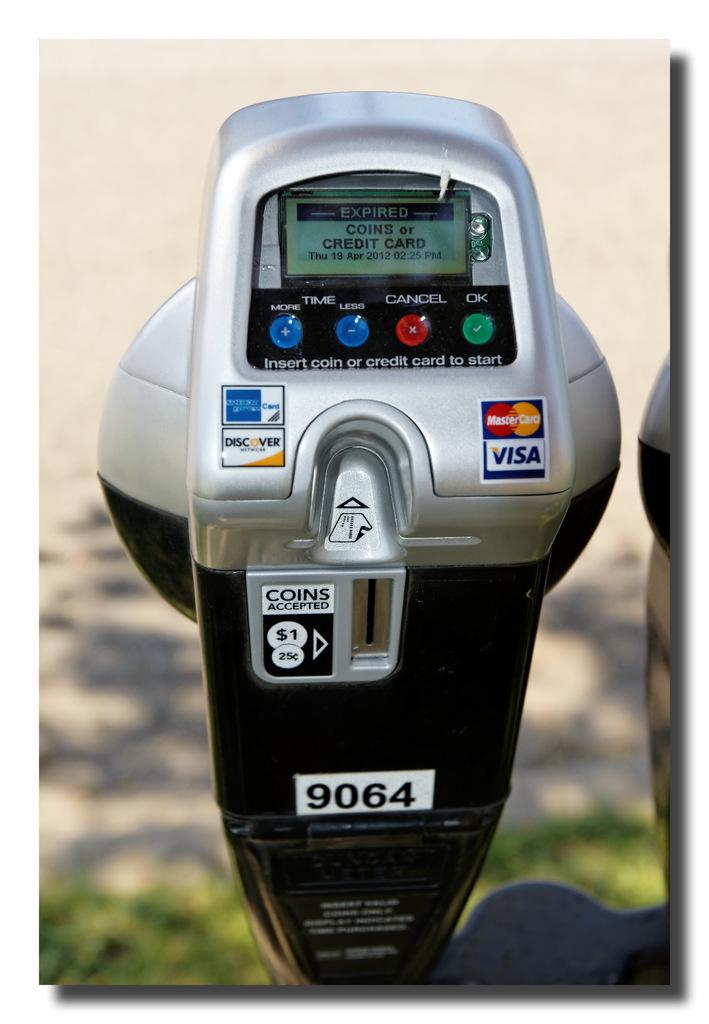What modes of payment are acceptable in the parking machine?
Make the answer very short. Coins or credit card. What is the number at the bottom of the meter?
Your answer should be compact. 9064. 